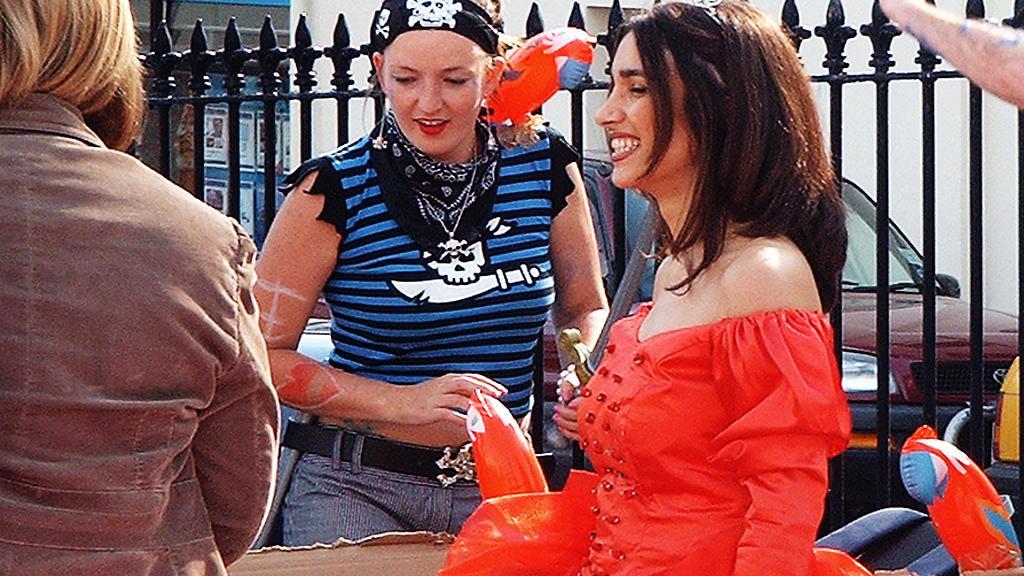Can you describe this image briefly? In the center of this picture we can see a woman wearing T-shirt, holding a metal object and standing. On the right we can see a woman wearing red color dress, smiling and seems to be standing and we can see the group of persons, inflatable objects, metal rods, car, wall, posters and some other objects. 